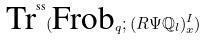<formula> <loc_0><loc_0><loc_500><loc_500>\text {Tr} ^ { \text {ss} } ( \text {Frob} _ { q } ; ( R \Psi \mathbb { Q } _ { l } ) _ { x } ^ { I } )</formula> 